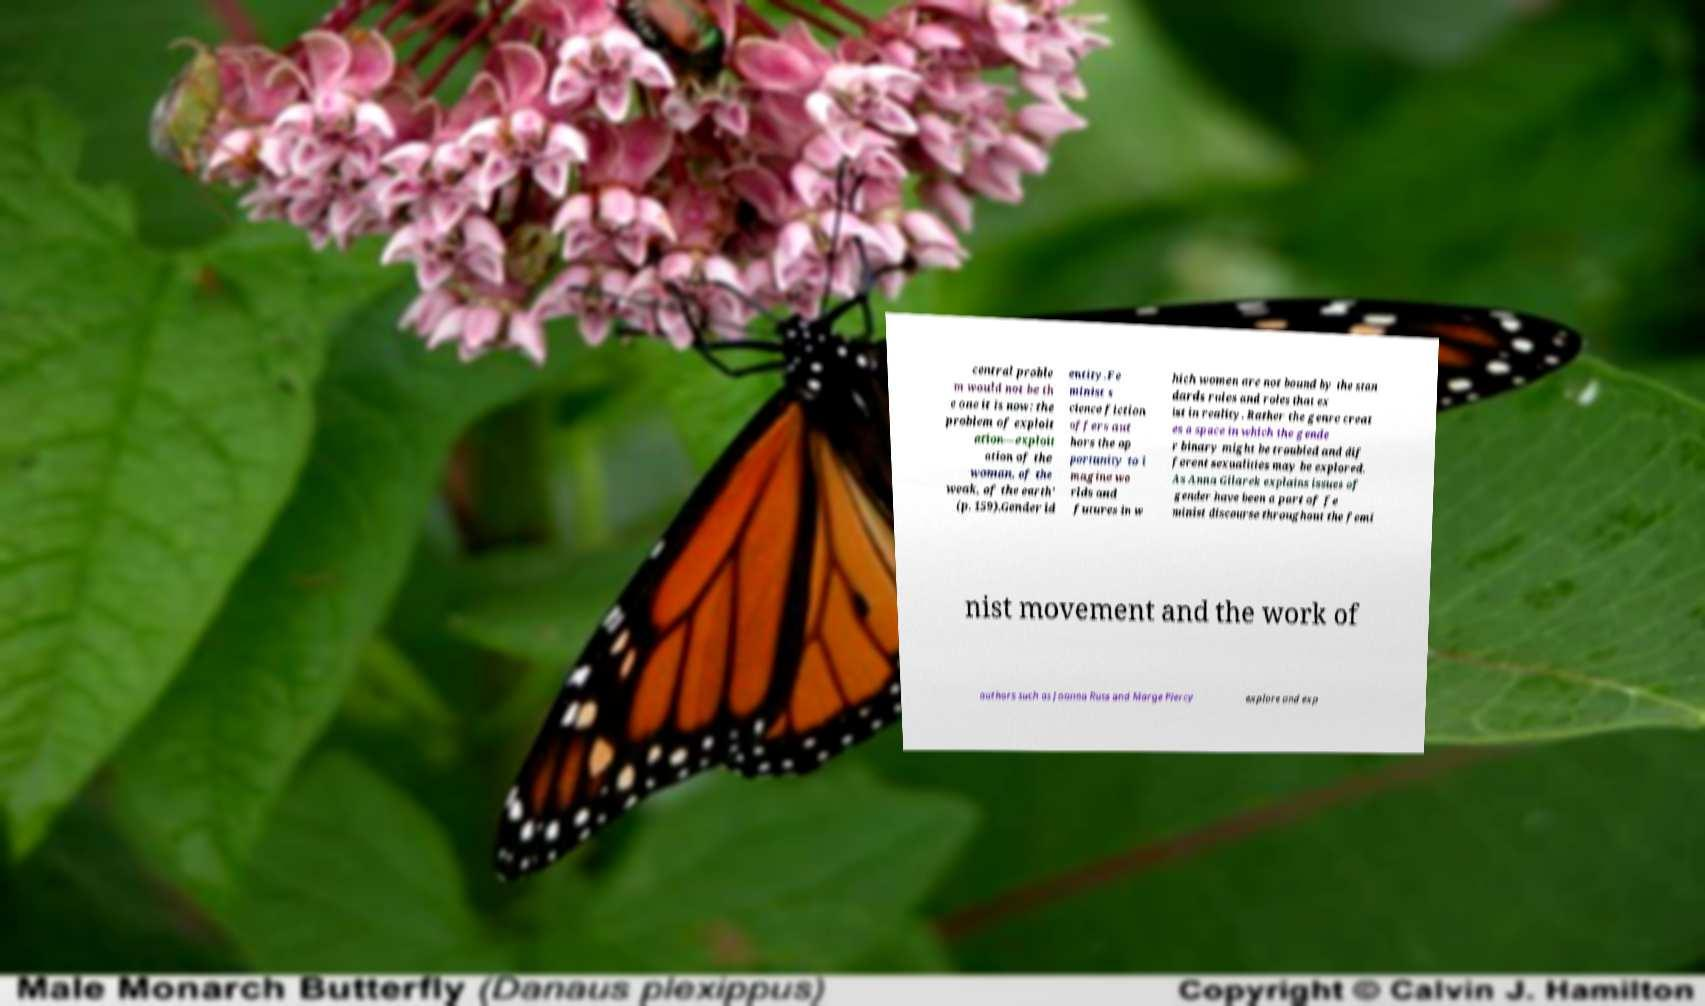Please read and relay the text visible in this image. What does it say? central proble m would not be th e one it is now: the problem of exploit ation—exploit ation of the woman, of the weak, of the earth' (p. 159).Gender id entity.Fe minist s cience fiction offers aut hors the op portunity to i magine wo rlds and futures in w hich women are not bound by the stan dards rules and roles that ex ist in reality. Rather the genre creat es a space in which the gende r binary might be troubled and dif ferent sexualities may be explored. As Anna Gilarek explains issues of gender have been a part of fe minist discourse throughout the femi nist movement and the work of authors such as Joanna Russ and Marge Piercy explore and exp 